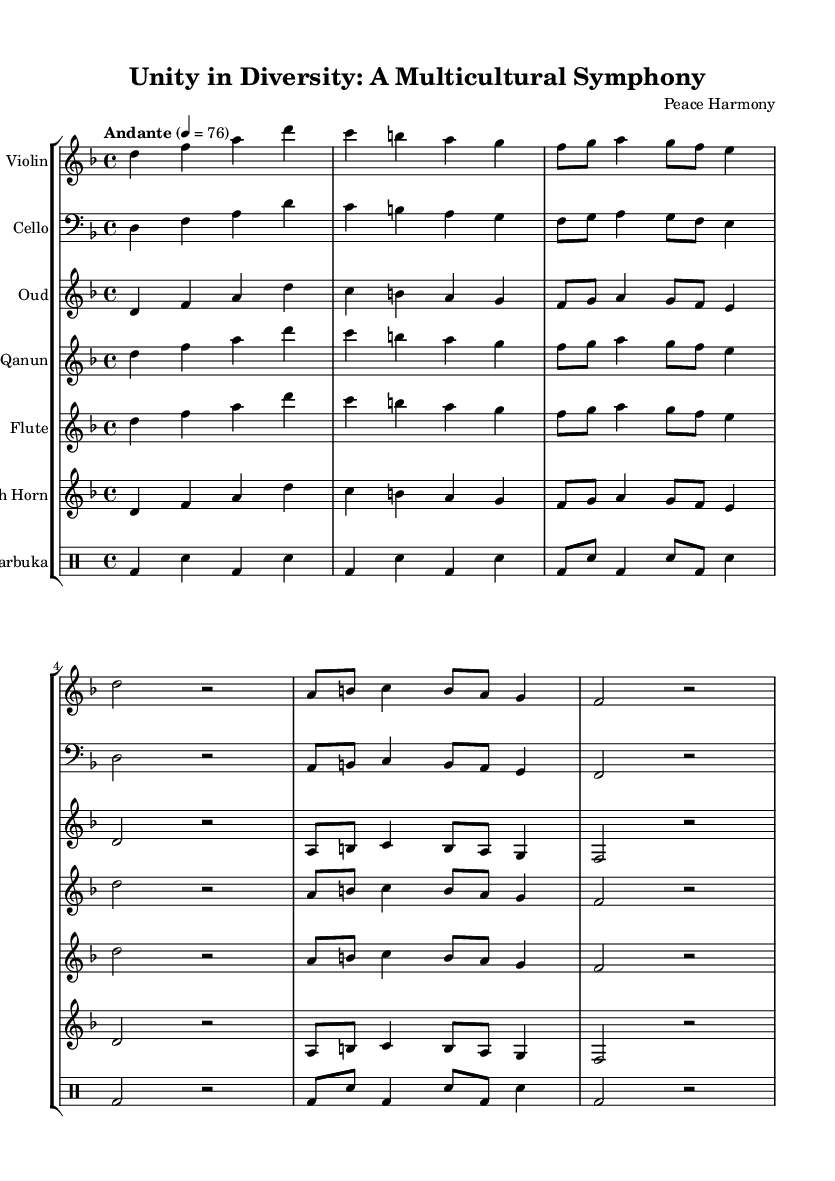What is the key signature of this music? The key signature is indicated by the 'key d minor' statement at the beginning of the score. It usually shows that the music primarily uses the notes D, E, F, G, A, B flat, and C.
Answer: D minor What is the time signature of this music? The time signature is notated as '4/4' following the 'time' statement in the global variable section. This means that there are four beats per measure, and each beat is a quarter note.
Answer: 4/4 What is the tempo marking of this music? The tempo is indicated as "Andante" with a metronomic marking of 76 beats per minute in the score. "Andante" suggests a moderate pace.
Answer: Andante How many instruments are included in this symphony? The score lists six distinct instrumental staffs and a drum staff, indicating the number of instruments. Counting these, we find that there are seven instruments represented.
Answer: Seven Which instrument is transposed in F? The score states 'transposition f' next to the French Horn, indicating that it is played in F and sounds a fifth lower than written.
Answer: French Horn What kind of drum is included in the symphony? The drumming part is labeled 'Darbuka,' which is a traditional Middle Eastern drum, indicating its cultural significance in the composition.
Answer: Darbuka What is the overall theme of this symphony? The title of the symphony, "Unity in Diversity: A Multicultural Symphony," directly suggests that the piece aims to blend diverse cultural musical traditions, focusing on collaboration and harmony among different musical backgrounds.
Answer: Unity in Diversity 